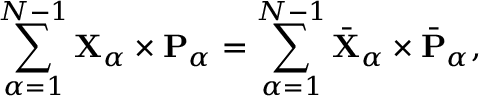Convert formula to latex. <formula><loc_0><loc_0><loc_500><loc_500>\sum _ { \alpha = 1 } ^ { N - 1 } { X } _ { \alpha } \times { P } _ { \alpha } = \sum _ { \alpha = 1 } ^ { N - 1 } \bar { X } _ { \alpha } \times \bar { P } _ { \alpha } ,</formula> 